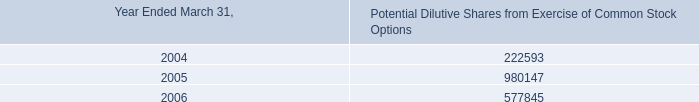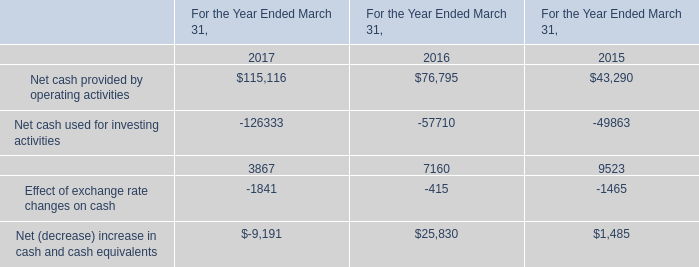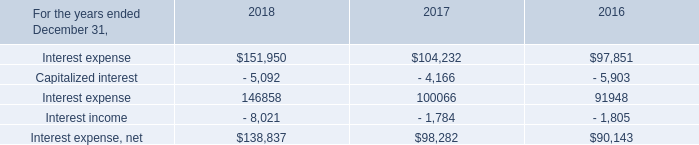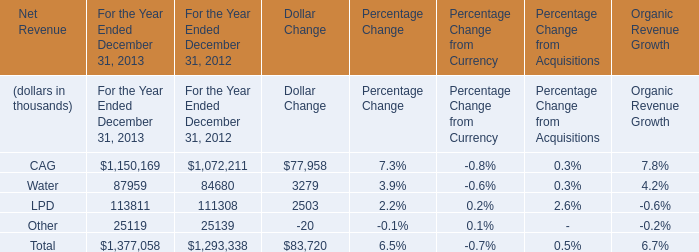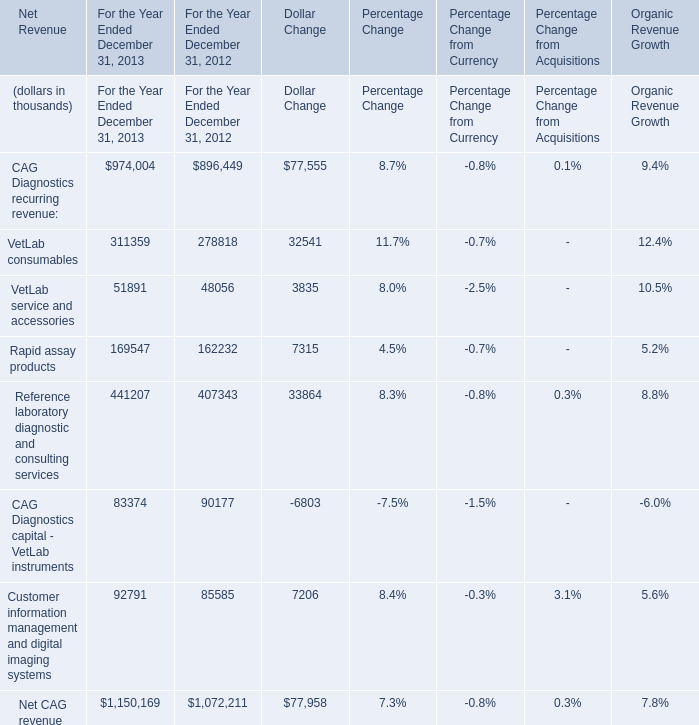What was the average value of Net Revenue of CAG, Net Revenue of Water, Net Revenue of LPD in 2012? (in thousand) 
Computations: (((1072211 + 84680) + 111308) / 3)
Answer: 422733.0. 